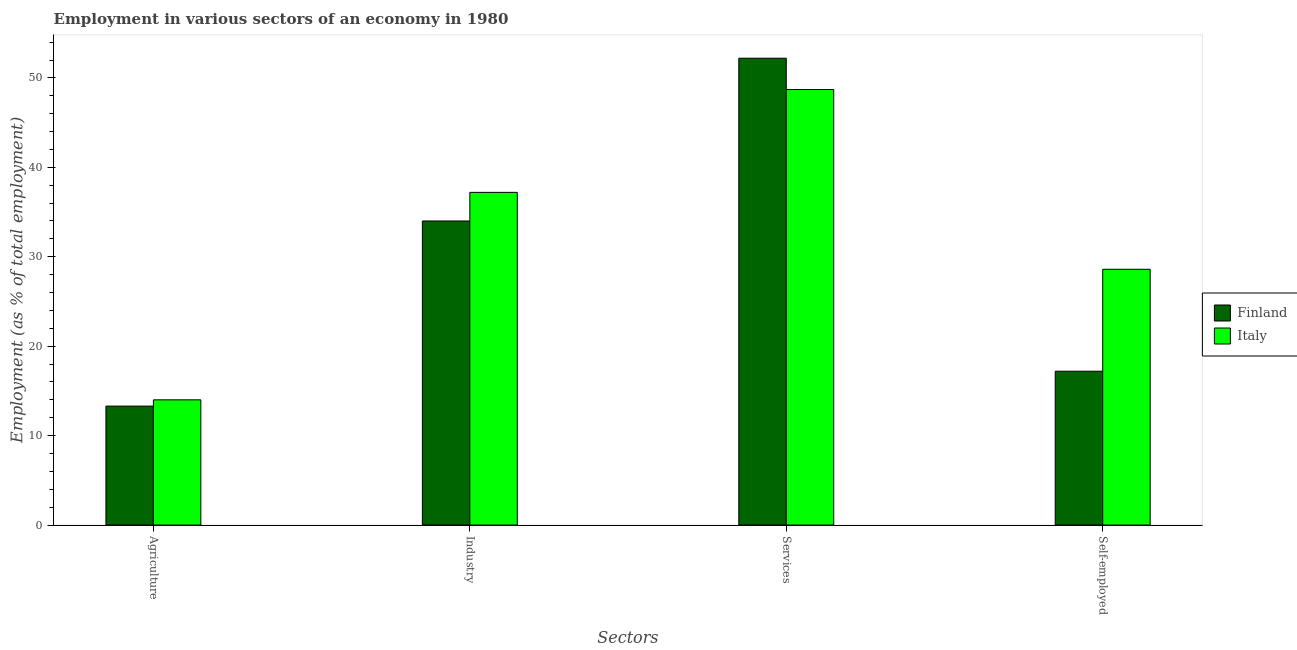Are the number of bars per tick equal to the number of legend labels?
Offer a terse response. Yes. Are the number of bars on each tick of the X-axis equal?
Your answer should be very brief. Yes. What is the label of the 1st group of bars from the left?
Keep it short and to the point. Agriculture. What is the percentage of workers in agriculture in Italy?
Ensure brevity in your answer.  14. Across all countries, what is the maximum percentage of self employed workers?
Your answer should be very brief. 28.6. Across all countries, what is the minimum percentage of workers in industry?
Provide a short and direct response. 34. What is the total percentage of workers in agriculture in the graph?
Give a very brief answer. 27.3. What is the difference between the percentage of workers in agriculture in Finland and that in Italy?
Provide a succinct answer. -0.7. What is the difference between the percentage of workers in agriculture in Finland and the percentage of workers in services in Italy?
Offer a very short reply. -35.4. What is the average percentage of workers in services per country?
Your answer should be very brief. 50.45. What is the difference between the percentage of self employed workers and percentage of workers in agriculture in Finland?
Your response must be concise. 3.9. What is the ratio of the percentage of workers in services in Italy to that in Finland?
Provide a short and direct response. 0.93. Is the difference between the percentage of workers in services in Finland and Italy greater than the difference between the percentage of workers in industry in Finland and Italy?
Keep it short and to the point. Yes. What is the difference between the highest and the second highest percentage of workers in industry?
Your response must be concise. 3.2. What is the difference between the highest and the lowest percentage of workers in industry?
Provide a short and direct response. 3.2. Is the sum of the percentage of workers in industry in Finland and Italy greater than the maximum percentage of workers in agriculture across all countries?
Offer a terse response. Yes. What does the 2nd bar from the right in Self-employed represents?
Offer a very short reply. Finland. How many countries are there in the graph?
Ensure brevity in your answer.  2. What is the difference between two consecutive major ticks on the Y-axis?
Offer a very short reply. 10. Does the graph contain grids?
Your answer should be very brief. No. How many legend labels are there?
Ensure brevity in your answer.  2. How are the legend labels stacked?
Your response must be concise. Vertical. What is the title of the graph?
Ensure brevity in your answer.  Employment in various sectors of an economy in 1980. Does "Malaysia" appear as one of the legend labels in the graph?
Your response must be concise. No. What is the label or title of the X-axis?
Your response must be concise. Sectors. What is the label or title of the Y-axis?
Your answer should be very brief. Employment (as % of total employment). What is the Employment (as % of total employment) in Finland in Agriculture?
Ensure brevity in your answer.  13.3. What is the Employment (as % of total employment) of Italy in Agriculture?
Your answer should be very brief. 14. What is the Employment (as % of total employment) of Italy in Industry?
Your answer should be very brief. 37.2. What is the Employment (as % of total employment) of Finland in Services?
Provide a succinct answer. 52.2. What is the Employment (as % of total employment) of Italy in Services?
Provide a short and direct response. 48.7. What is the Employment (as % of total employment) of Finland in Self-employed?
Your answer should be very brief. 17.2. What is the Employment (as % of total employment) in Italy in Self-employed?
Your answer should be very brief. 28.6. Across all Sectors, what is the maximum Employment (as % of total employment) of Finland?
Your answer should be very brief. 52.2. Across all Sectors, what is the maximum Employment (as % of total employment) in Italy?
Offer a terse response. 48.7. Across all Sectors, what is the minimum Employment (as % of total employment) in Finland?
Ensure brevity in your answer.  13.3. What is the total Employment (as % of total employment) of Finland in the graph?
Offer a terse response. 116.7. What is the total Employment (as % of total employment) in Italy in the graph?
Provide a short and direct response. 128.5. What is the difference between the Employment (as % of total employment) in Finland in Agriculture and that in Industry?
Give a very brief answer. -20.7. What is the difference between the Employment (as % of total employment) of Italy in Agriculture and that in Industry?
Make the answer very short. -23.2. What is the difference between the Employment (as % of total employment) of Finland in Agriculture and that in Services?
Provide a succinct answer. -38.9. What is the difference between the Employment (as % of total employment) in Italy in Agriculture and that in Services?
Provide a succinct answer. -34.7. What is the difference between the Employment (as % of total employment) in Finland in Agriculture and that in Self-employed?
Your response must be concise. -3.9. What is the difference between the Employment (as % of total employment) of Italy in Agriculture and that in Self-employed?
Provide a short and direct response. -14.6. What is the difference between the Employment (as % of total employment) in Finland in Industry and that in Services?
Ensure brevity in your answer.  -18.2. What is the difference between the Employment (as % of total employment) in Italy in Industry and that in Services?
Ensure brevity in your answer.  -11.5. What is the difference between the Employment (as % of total employment) of Finland in Services and that in Self-employed?
Offer a very short reply. 35. What is the difference between the Employment (as % of total employment) of Italy in Services and that in Self-employed?
Your answer should be compact. 20.1. What is the difference between the Employment (as % of total employment) in Finland in Agriculture and the Employment (as % of total employment) in Italy in Industry?
Keep it short and to the point. -23.9. What is the difference between the Employment (as % of total employment) in Finland in Agriculture and the Employment (as % of total employment) in Italy in Services?
Give a very brief answer. -35.4. What is the difference between the Employment (as % of total employment) in Finland in Agriculture and the Employment (as % of total employment) in Italy in Self-employed?
Your answer should be compact. -15.3. What is the difference between the Employment (as % of total employment) in Finland in Industry and the Employment (as % of total employment) in Italy in Services?
Give a very brief answer. -14.7. What is the difference between the Employment (as % of total employment) of Finland in Services and the Employment (as % of total employment) of Italy in Self-employed?
Provide a short and direct response. 23.6. What is the average Employment (as % of total employment) of Finland per Sectors?
Ensure brevity in your answer.  29.18. What is the average Employment (as % of total employment) of Italy per Sectors?
Offer a terse response. 32.12. What is the ratio of the Employment (as % of total employment) in Finland in Agriculture to that in Industry?
Offer a very short reply. 0.39. What is the ratio of the Employment (as % of total employment) in Italy in Agriculture to that in Industry?
Your answer should be compact. 0.38. What is the ratio of the Employment (as % of total employment) in Finland in Agriculture to that in Services?
Provide a succinct answer. 0.25. What is the ratio of the Employment (as % of total employment) of Italy in Agriculture to that in Services?
Offer a very short reply. 0.29. What is the ratio of the Employment (as % of total employment) of Finland in Agriculture to that in Self-employed?
Keep it short and to the point. 0.77. What is the ratio of the Employment (as % of total employment) of Italy in Agriculture to that in Self-employed?
Offer a terse response. 0.49. What is the ratio of the Employment (as % of total employment) in Finland in Industry to that in Services?
Keep it short and to the point. 0.65. What is the ratio of the Employment (as % of total employment) of Italy in Industry to that in Services?
Your answer should be compact. 0.76. What is the ratio of the Employment (as % of total employment) in Finland in Industry to that in Self-employed?
Offer a terse response. 1.98. What is the ratio of the Employment (as % of total employment) in Italy in Industry to that in Self-employed?
Ensure brevity in your answer.  1.3. What is the ratio of the Employment (as % of total employment) in Finland in Services to that in Self-employed?
Offer a terse response. 3.03. What is the ratio of the Employment (as % of total employment) in Italy in Services to that in Self-employed?
Offer a very short reply. 1.7. What is the difference between the highest and the lowest Employment (as % of total employment) in Finland?
Your response must be concise. 38.9. What is the difference between the highest and the lowest Employment (as % of total employment) of Italy?
Ensure brevity in your answer.  34.7. 